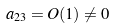Convert formula to latex. <formula><loc_0><loc_0><loc_500><loc_500>a _ { 2 3 } = O ( 1 ) \ne 0</formula> 